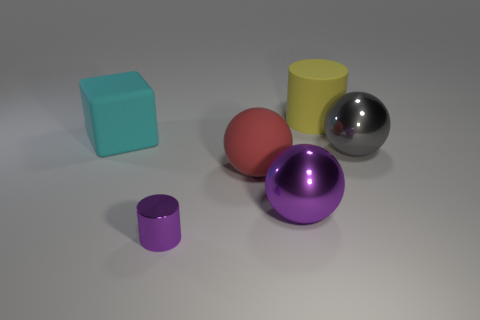Add 4 small yellow things. How many objects exist? 10 Subtract all large purple spheres. How many spheres are left? 2 Subtract all red spheres. How many spheres are left? 2 Subtract all cylinders. How many objects are left? 4 Subtract all brown balls. Subtract all yellow cylinders. How many balls are left? 3 Subtract all purple spheres. How many purple cylinders are left? 1 Subtract all big yellow things. Subtract all cylinders. How many objects are left? 3 Add 1 red things. How many red things are left? 2 Add 4 cyan cubes. How many cyan cubes exist? 5 Subtract 0 red cylinders. How many objects are left? 6 